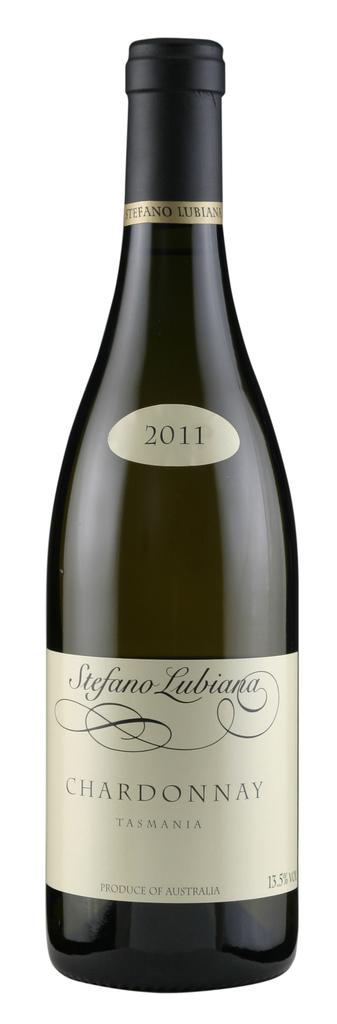What year was this wine made?
Offer a very short reply. 2011. What is this brand of wine?
Offer a very short reply. Stefano lubiana. 